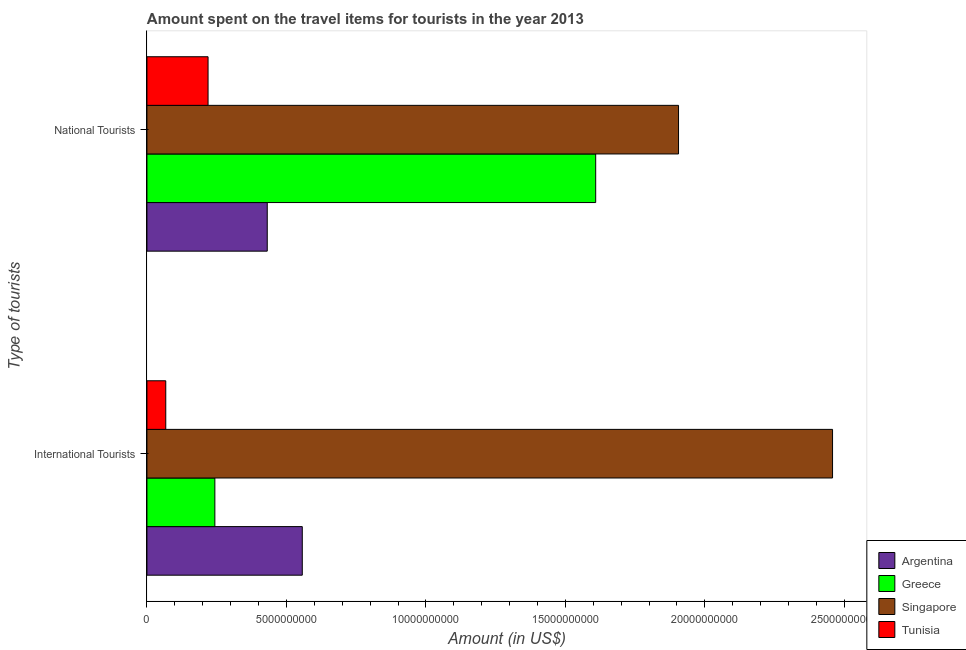Are the number of bars per tick equal to the number of legend labels?
Make the answer very short. Yes. How many bars are there on the 1st tick from the bottom?
Give a very brief answer. 4. What is the label of the 2nd group of bars from the top?
Make the answer very short. International Tourists. What is the amount spent on travel items of international tourists in Argentina?
Offer a terse response. 5.57e+09. Across all countries, what is the maximum amount spent on travel items of national tourists?
Give a very brief answer. 1.91e+1. Across all countries, what is the minimum amount spent on travel items of national tourists?
Ensure brevity in your answer.  2.19e+09. In which country was the amount spent on travel items of national tourists maximum?
Make the answer very short. Singapore. In which country was the amount spent on travel items of national tourists minimum?
Keep it short and to the point. Tunisia. What is the total amount spent on travel items of national tourists in the graph?
Provide a short and direct response. 4.16e+1. What is the difference between the amount spent on travel items of national tourists in Tunisia and that in Argentina?
Your answer should be compact. -2.12e+09. What is the difference between the amount spent on travel items of international tourists in Tunisia and the amount spent on travel items of national tourists in Singapore?
Your answer should be compact. -1.84e+1. What is the average amount spent on travel items of international tourists per country?
Offer a very short reply. 8.31e+09. What is the difference between the amount spent on travel items of international tourists and amount spent on travel items of national tourists in Tunisia?
Your answer should be compact. -1.52e+09. What is the ratio of the amount spent on travel items of international tourists in Argentina to that in Singapore?
Your answer should be compact. 0.23. Is the amount spent on travel items of national tourists in Tunisia less than that in Argentina?
Make the answer very short. Yes. What does the 1st bar from the top in International Tourists represents?
Ensure brevity in your answer.  Tunisia. Are all the bars in the graph horizontal?
Your answer should be very brief. Yes. Does the graph contain any zero values?
Your answer should be compact. No. Does the graph contain grids?
Keep it short and to the point. No. Where does the legend appear in the graph?
Make the answer very short. Bottom right. How many legend labels are there?
Provide a short and direct response. 4. What is the title of the graph?
Your answer should be very brief. Amount spent on the travel items for tourists in the year 2013. What is the label or title of the Y-axis?
Give a very brief answer. Type of tourists. What is the Amount (in US$) of Argentina in International Tourists?
Offer a very short reply. 5.57e+09. What is the Amount (in US$) in Greece in International Tourists?
Keep it short and to the point. 2.44e+09. What is the Amount (in US$) in Singapore in International Tourists?
Ensure brevity in your answer.  2.46e+1. What is the Amount (in US$) of Tunisia in International Tourists?
Offer a terse response. 6.75e+08. What is the Amount (in US$) of Argentina in National Tourists?
Offer a very short reply. 4.31e+09. What is the Amount (in US$) in Greece in National Tourists?
Give a very brief answer. 1.61e+1. What is the Amount (in US$) of Singapore in National Tourists?
Offer a very short reply. 1.91e+1. What is the Amount (in US$) of Tunisia in National Tourists?
Provide a succinct answer. 2.19e+09. Across all Type of tourists, what is the maximum Amount (in US$) of Argentina?
Provide a succinct answer. 5.57e+09. Across all Type of tourists, what is the maximum Amount (in US$) of Greece?
Offer a terse response. 1.61e+1. Across all Type of tourists, what is the maximum Amount (in US$) in Singapore?
Offer a terse response. 2.46e+1. Across all Type of tourists, what is the maximum Amount (in US$) in Tunisia?
Your answer should be compact. 2.19e+09. Across all Type of tourists, what is the minimum Amount (in US$) of Argentina?
Keep it short and to the point. 4.31e+09. Across all Type of tourists, what is the minimum Amount (in US$) of Greece?
Provide a succinct answer. 2.44e+09. Across all Type of tourists, what is the minimum Amount (in US$) of Singapore?
Keep it short and to the point. 1.91e+1. Across all Type of tourists, what is the minimum Amount (in US$) in Tunisia?
Your answer should be compact. 6.75e+08. What is the total Amount (in US$) of Argentina in the graph?
Ensure brevity in your answer.  9.88e+09. What is the total Amount (in US$) in Greece in the graph?
Give a very brief answer. 1.85e+1. What is the total Amount (in US$) in Singapore in the graph?
Offer a terse response. 4.36e+1. What is the total Amount (in US$) in Tunisia in the graph?
Provide a succinct answer. 2.87e+09. What is the difference between the Amount (in US$) in Argentina in International Tourists and that in National Tourists?
Keep it short and to the point. 1.26e+09. What is the difference between the Amount (in US$) of Greece in International Tourists and that in National Tourists?
Your answer should be very brief. -1.37e+1. What is the difference between the Amount (in US$) in Singapore in International Tourists and that in National Tourists?
Give a very brief answer. 5.52e+09. What is the difference between the Amount (in US$) of Tunisia in International Tourists and that in National Tourists?
Make the answer very short. -1.52e+09. What is the difference between the Amount (in US$) in Argentina in International Tourists and the Amount (in US$) in Greece in National Tourists?
Make the answer very short. -1.05e+1. What is the difference between the Amount (in US$) in Argentina in International Tourists and the Amount (in US$) in Singapore in National Tourists?
Make the answer very short. -1.35e+1. What is the difference between the Amount (in US$) in Argentina in International Tourists and the Amount (in US$) in Tunisia in National Tourists?
Give a very brief answer. 3.38e+09. What is the difference between the Amount (in US$) of Greece in International Tourists and the Amount (in US$) of Singapore in National Tourists?
Provide a short and direct response. -1.66e+1. What is the difference between the Amount (in US$) of Greece in International Tourists and the Amount (in US$) of Tunisia in National Tourists?
Keep it short and to the point. 2.44e+08. What is the difference between the Amount (in US$) in Singapore in International Tourists and the Amount (in US$) in Tunisia in National Tourists?
Provide a succinct answer. 2.24e+1. What is the average Amount (in US$) in Argentina per Type of tourists?
Your answer should be compact. 4.94e+09. What is the average Amount (in US$) of Greece per Type of tourists?
Provide a succinct answer. 9.26e+09. What is the average Amount (in US$) of Singapore per Type of tourists?
Your answer should be very brief. 2.18e+1. What is the average Amount (in US$) of Tunisia per Type of tourists?
Make the answer very short. 1.43e+09. What is the difference between the Amount (in US$) of Argentina and Amount (in US$) of Greece in International Tourists?
Ensure brevity in your answer.  3.13e+09. What is the difference between the Amount (in US$) of Argentina and Amount (in US$) of Singapore in International Tourists?
Make the answer very short. -1.90e+1. What is the difference between the Amount (in US$) in Argentina and Amount (in US$) in Tunisia in International Tourists?
Your answer should be compact. 4.89e+09. What is the difference between the Amount (in US$) in Greece and Amount (in US$) in Singapore in International Tourists?
Provide a succinct answer. -2.21e+1. What is the difference between the Amount (in US$) in Greece and Amount (in US$) in Tunisia in International Tourists?
Your answer should be compact. 1.76e+09. What is the difference between the Amount (in US$) in Singapore and Amount (in US$) in Tunisia in International Tourists?
Give a very brief answer. 2.39e+1. What is the difference between the Amount (in US$) in Argentina and Amount (in US$) in Greece in National Tourists?
Make the answer very short. -1.18e+1. What is the difference between the Amount (in US$) in Argentina and Amount (in US$) in Singapore in National Tourists?
Your response must be concise. -1.47e+1. What is the difference between the Amount (in US$) of Argentina and Amount (in US$) of Tunisia in National Tourists?
Your response must be concise. 2.12e+09. What is the difference between the Amount (in US$) of Greece and Amount (in US$) of Singapore in National Tourists?
Your answer should be very brief. -2.97e+09. What is the difference between the Amount (in US$) in Greece and Amount (in US$) in Tunisia in National Tourists?
Your response must be concise. 1.39e+1. What is the difference between the Amount (in US$) of Singapore and Amount (in US$) of Tunisia in National Tourists?
Keep it short and to the point. 1.69e+1. What is the ratio of the Amount (in US$) in Argentina in International Tourists to that in National Tourists?
Offer a very short reply. 1.29. What is the ratio of the Amount (in US$) of Greece in International Tourists to that in National Tourists?
Ensure brevity in your answer.  0.15. What is the ratio of the Amount (in US$) in Singapore in International Tourists to that in National Tourists?
Provide a short and direct response. 1.29. What is the ratio of the Amount (in US$) of Tunisia in International Tourists to that in National Tourists?
Provide a succinct answer. 0.31. What is the difference between the highest and the second highest Amount (in US$) in Argentina?
Give a very brief answer. 1.26e+09. What is the difference between the highest and the second highest Amount (in US$) in Greece?
Provide a short and direct response. 1.37e+1. What is the difference between the highest and the second highest Amount (in US$) in Singapore?
Keep it short and to the point. 5.52e+09. What is the difference between the highest and the second highest Amount (in US$) of Tunisia?
Your answer should be compact. 1.52e+09. What is the difference between the highest and the lowest Amount (in US$) of Argentina?
Provide a short and direct response. 1.26e+09. What is the difference between the highest and the lowest Amount (in US$) of Greece?
Your answer should be very brief. 1.37e+1. What is the difference between the highest and the lowest Amount (in US$) of Singapore?
Offer a terse response. 5.52e+09. What is the difference between the highest and the lowest Amount (in US$) in Tunisia?
Your answer should be very brief. 1.52e+09. 